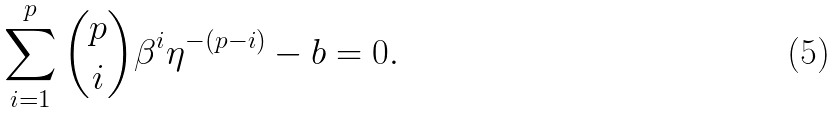<formula> <loc_0><loc_0><loc_500><loc_500>\sum _ { i = 1 } ^ { p } \binom { p } { i } \beta ^ { i } \eta ^ { - ( p - i ) } - b = 0 .</formula> 